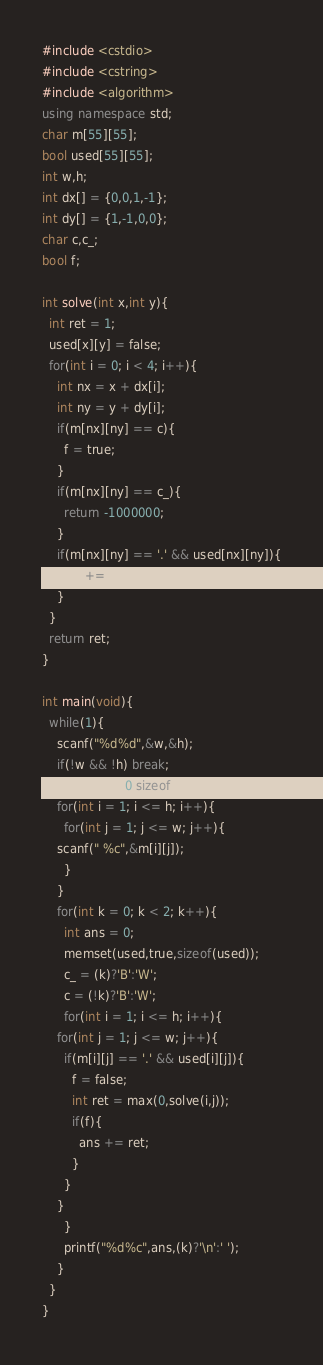<code> <loc_0><loc_0><loc_500><loc_500><_C++_>#include <cstdio>
#include <cstring>
#include <algorithm>
using namespace std;
char m[55][55];
bool used[55][55];
int w,h;
int dx[] = {0,0,1,-1};
int dy[] = {1,-1,0,0};
char c,c_;
bool f;

int solve(int x,int y){
  int ret = 1;
  used[x][y] = false;
  for(int i = 0; i < 4; i++){
    int nx = x + dx[i];
    int ny = y + dy[i];
    if(m[nx][ny] == c){
      f = true;
    }
    if(m[nx][ny] == c_){
      return -1000000;
    }
    if(m[nx][ny] == '.' && used[nx][ny]){
      ret += solve(nx,ny);
    }
  }
  return ret;
}

int main(void){
  while(1){
    scanf("%d%d",&w,&h);
    if(!w && !h) break;
    memset(m,0,sizeof(m));
    for(int i = 1; i <= h; i++){
      for(int j = 1; j <= w; j++){
	scanf(" %c",&m[i][j]);
      }
    }
    for(int k = 0; k < 2; k++){
      int ans = 0;
      memset(used,true,sizeof(used));
      c_ = (k)?'B':'W';
      c = (!k)?'B':'W';
      for(int i = 1; i <= h; i++){
	for(int j = 1; j <= w; j++){
	  if(m[i][j] == '.' && used[i][j]){
	    f = false;
	    int ret = max(0,solve(i,j));
	    if(f){
	      ans += ret;
	    }
	  }
	}
      }
      printf("%d%c",ans,(k)?'\n':' ');
    }
  }
}</code> 